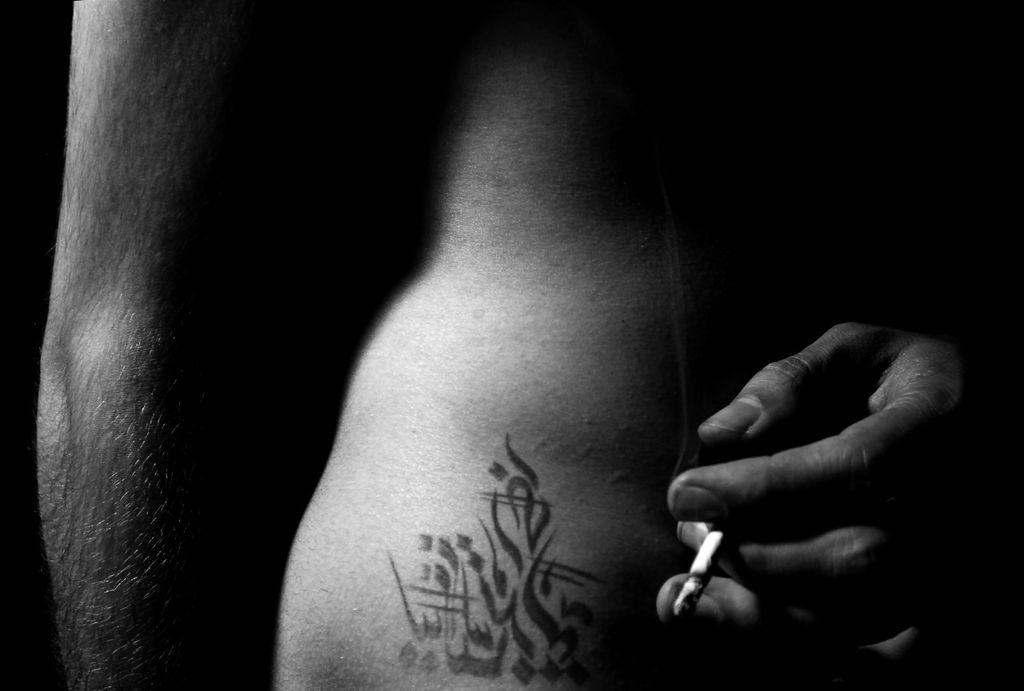What is present in the image? There is a person in the image. What is the person holding in their hand? The person is holding a cigarette in their hand. Can you describe the lighting conditions in the image? The image may have been taken during the night. What type of stew is being prepared by the person in the image? There is no indication of any stew or cooking activity in the image. 